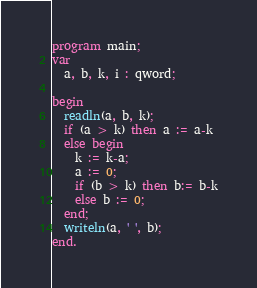Convert code to text. <code><loc_0><loc_0><loc_500><loc_500><_Pascal_>program main;
var
  a, b, k, i : qword;

begin
  readln(a, b, k);
  if (a > k) then a := a-k
  else begin
    k := k-a;
    a := 0;
    if (b > k) then b:= b-k
    else b := 0;
  end;
  writeln(a, ' ', b);
end.
</code> 